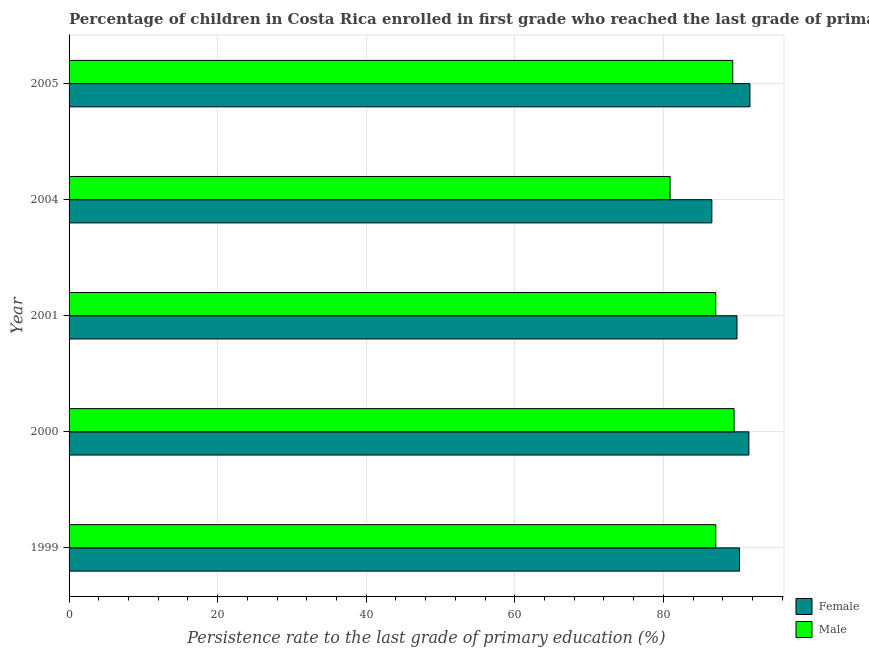How many different coloured bars are there?
Keep it short and to the point. 2. How many groups of bars are there?
Provide a succinct answer. 5. Are the number of bars per tick equal to the number of legend labels?
Provide a short and direct response. Yes. How many bars are there on the 3rd tick from the bottom?
Offer a terse response. 2. What is the label of the 2nd group of bars from the top?
Your answer should be very brief. 2004. In how many cases, is the number of bars for a given year not equal to the number of legend labels?
Provide a short and direct response. 0. What is the persistence rate of female students in 2005?
Make the answer very short. 91.65. Across all years, what is the maximum persistence rate of male students?
Provide a short and direct response. 89.52. Across all years, what is the minimum persistence rate of female students?
Make the answer very short. 86.52. In which year was the persistence rate of male students maximum?
Make the answer very short. 2000. In which year was the persistence rate of male students minimum?
Provide a short and direct response. 2004. What is the total persistence rate of male students in the graph?
Your answer should be very brief. 433.84. What is the difference between the persistence rate of female students in 1999 and that in 2000?
Ensure brevity in your answer.  -1.26. What is the difference between the persistence rate of female students in 2000 and the persistence rate of male students in 1999?
Provide a succinct answer. 4.45. What is the average persistence rate of female students per year?
Provide a short and direct response. 89.96. In the year 2004, what is the difference between the persistence rate of female students and persistence rate of male students?
Your answer should be very brief. 5.62. In how many years, is the persistence rate of female students greater than 92 %?
Offer a very short reply. 0. Is the persistence rate of female students in 2000 less than that in 2001?
Provide a short and direct response. No. Is the difference between the persistence rate of female students in 2001 and 2005 greater than the difference between the persistence rate of male students in 2001 and 2005?
Keep it short and to the point. Yes. What is the difference between the highest and the second highest persistence rate of female students?
Provide a succinct answer. 0.14. What is the difference between the highest and the lowest persistence rate of female students?
Ensure brevity in your answer.  5.13. Are all the bars in the graph horizontal?
Provide a short and direct response. Yes. How many years are there in the graph?
Your answer should be compact. 5. What is the difference between two consecutive major ticks on the X-axis?
Offer a terse response. 20. Does the graph contain any zero values?
Ensure brevity in your answer.  No. Where does the legend appear in the graph?
Your answer should be compact. Bottom right. How are the legend labels stacked?
Provide a succinct answer. Vertical. What is the title of the graph?
Provide a succinct answer. Percentage of children in Costa Rica enrolled in first grade who reached the last grade of primary education. Does "Diesel" appear as one of the legend labels in the graph?
Offer a very short reply. No. What is the label or title of the X-axis?
Your response must be concise. Persistence rate to the last grade of primary education (%). What is the Persistence rate to the last grade of primary education (%) in Female in 1999?
Give a very brief answer. 90.24. What is the Persistence rate to the last grade of primary education (%) in Male in 1999?
Ensure brevity in your answer.  87.05. What is the Persistence rate to the last grade of primary education (%) in Female in 2000?
Keep it short and to the point. 91.5. What is the Persistence rate to the last grade of primary education (%) of Male in 2000?
Provide a succinct answer. 89.52. What is the Persistence rate to the last grade of primary education (%) in Female in 2001?
Offer a very short reply. 89.9. What is the Persistence rate to the last grade of primary education (%) of Male in 2001?
Provide a short and direct response. 87.04. What is the Persistence rate to the last grade of primary education (%) of Female in 2004?
Your answer should be compact. 86.52. What is the Persistence rate to the last grade of primary education (%) of Male in 2004?
Offer a very short reply. 80.9. What is the Persistence rate to the last grade of primary education (%) of Female in 2005?
Offer a very short reply. 91.65. What is the Persistence rate to the last grade of primary education (%) of Male in 2005?
Make the answer very short. 89.33. Across all years, what is the maximum Persistence rate to the last grade of primary education (%) of Female?
Your answer should be compact. 91.65. Across all years, what is the maximum Persistence rate to the last grade of primary education (%) in Male?
Make the answer very short. 89.52. Across all years, what is the minimum Persistence rate to the last grade of primary education (%) in Female?
Offer a very short reply. 86.52. Across all years, what is the minimum Persistence rate to the last grade of primary education (%) of Male?
Provide a short and direct response. 80.9. What is the total Persistence rate to the last grade of primary education (%) of Female in the graph?
Make the answer very short. 449.81. What is the total Persistence rate to the last grade of primary education (%) of Male in the graph?
Make the answer very short. 433.84. What is the difference between the Persistence rate to the last grade of primary education (%) in Female in 1999 and that in 2000?
Your answer should be very brief. -1.26. What is the difference between the Persistence rate to the last grade of primary education (%) in Male in 1999 and that in 2000?
Offer a terse response. -2.47. What is the difference between the Persistence rate to the last grade of primary education (%) in Female in 1999 and that in 2001?
Offer a very short reply. 0.34. What is the difference between the Persistence rate to the last grade of primary education (%) in Male in 1999 and that in 2001?
Provide a succinct answer. 0.01. What is the difference between the Persistence rate to the last grade of primary education (%) in Female in 1999 and that in 2004?
Provide a short and direct response. 3.72. What is the difference between the Persistence rate to the last grade of primary education (%) of Male in 1999 and that in 2004?
Offer a terse response. 6.15. What is the difference between the Persistence rate to the last grade of primary education (%) of Female in 1999 and that in 2005?
Provide a succinct answer. -1.41. What is the difference between the Persistence rate to the last grade of primary education (%) in Male in 1999 and that in 2005?
Make the answer very short. -2.28. What is the difference between the Persistence rate to the last grade of primary education (%) in Female in 2000 and that in 2001?
Provide a succinct answer. 1.6. What is the difference between the Persistence rate to the last grade of primary education (%) in Male in 2000 and that in 2001?
Provide a succinct answer. 2.47. What is the difference between the Persistence rate to the last grade of primary education (%) of Female in 2000 and that in 2004?
Your answer should be very brief. 4.98. What is the difference between the Persistence rate to the last grade of primary education (%) of Male in 2000 and that in 2004?
Provide a succinct answer. 8.62. What is the difference between the Persistence rate to the last grade of primary education (%) of Female in 2000 and that in 2005?
Provide a succinct answer. -0.14. What is the difference between the Persistence rate to the last grade of primary education (%) of Male in 2000 and that in 2005?
Provide a succinct answer. 0.18. What is the difference between the Persistence rate to the last grade of primary education (%) in Female in 2001 and that in 2004?
Your answer should be very brief. 3.38. What is the difference between the Persistence rate to the last grade of primary education (%) of Male in 2001 and that in 2004?
Give a very brief answer. 6.14. What is the difference between the Persistence rate to the last grade of primary education (%) of Female in 2001 and that in 2005?
Offer a terse response. -1.75. What is the difference between the Persistence rate to the last grade of primary education (%) in Male in 2001 and that in 2005?
Provide a succinct answer. -2.29. What is the difference between the Persistence rate to the last grade of primary education (%) of Female in 2004 and that in 2005?
Offer a very short reply. -5.13. What is the difference between the Persistence rate to the last grade of primary education (%) in Male in 2004 and that in 2005?
Provide a succinct answer. -8.44. What is the difference between the Persistence rate to the last grade of primary education (%) of Female in 1999 and the Persistence rate to the last grade of primary education (%) of Male in 2000?
Give a very brief answer. 0.73. What is the difference between the Persistence rate to the last grade of primary education (%) in Female in 1999 and the Persistence rate to the last grade of primary education (%) in Male in 2001?
Ensure brevity in your answer.  3.2. What is the difference between the Persistence rate to the last grade of primary education (%) of Female in 1999 and the Persistence rate to the last grade of primary education (%) of Male in 2004?
Provide a short and direct response. 9.34. What is the difference between the Persistence rate to the last grade of primary education (%) of Female in 1999 and the Persistence rate to the last grade of primary education (%) of Male in 2005?
Your response must be concise. 0.91. What is the difference between the Persistence rate to the last grade of primary education (%) of Female in 2000 and the Persistence rate to the last grade of primary education (%) of Male in 2001?
Provide a short and direct response. 4.46. What is the difference between the Persistence rate to the last grade of primary education (%) of Female in 2000 and the Persistence rate to the last grade of primary education (%) of Male in 2004?
Your answer should be compact. 10.61. What is the difference between the Persistence rate to the last grade of primary education (%) in Female in 2000 and the Persistence rate to the last grade of primary education (%) in Male in 2005?
Give a very brief answer. 2.17. What is the difference between the Persistence rate to the last grade of primary education (%) of Female in 2001 and the Persistence rate to the last grade of primary education (%) of Male in 2004?
Offer a very short reply. 9. What is the difference between the Persistence rate to the last grade of primary education (%) in Female in 2001 and the Persistence rate to the last grade of primary education (%) in Male in 2005?
Give a very brief answer. 0.57. What is the difference between the Persistence rate to the last grade of primary education (%) in Female in 2004 and the Persistence rate to the last grade of primary education (%) in Male in 2005?
Offer a terse response. -2.81. What is the average Persistence rate to the last grade of primary education (%) in Female per year?
Ensure brevity in your answer.  89.96. What is the average Persistence rate to the last grade of primary education (%) in Male per year?
Give a very brief answer. 86.77. In the year 1999, what is the difference between the Persistence rate to the last grade of primary education (%) of Female and Persistence rate to the last grade of primary education (%) of Male?
Provide a succinct answer. 3.19. In the year 2000, what is the difference between the Persistence rate to the last grade of primary education (%) in Female and Persistence rate to the last grade of primary education (%) in Male?
Make the answer very short. 1.99. In the year 2001, what is the difference between the Persistence rate to the last grade of primary education (%) of Female and Persistence rate to the last grade of primary education (%) of Male?
Make the answer very short. 2.86. In the year 2004, what is the difference between the Persistence rate to the last grade of primary education (%) in Female and Persistence rate to the last grade of primary education (%) in Male?
Offer a very short reply. 5.62. In the year 2005, what is the difference between the Persistence rate to the last grade of primary education (%) in Female and Persistence rate to the last grade of primary education (%) in Male?
Offer a very short reply. 2.31. What is the ratio of the Persistence rate to the last grade of primary education (%) in Female in 1999 to that in 2000?
Offer a very short reply. 0.99. What is the ratio of the Persistence rate to the last grade of primary education (%) in Male in 1999 to that in 2000?
Your answer should be compact. 0.97. What is the ratio of the Persistence rate to the last grade of primary education (%) in Male in 1999 to that in 2001?
Ensure brevity in your answer.  1. What is the ratio of the Persistence rate to the last grade of primary education (%) in Female in 1999 to that in 2004?
Your answer should be compact. 1.04. What is the ratio of the Persistence rate to the last grade of primary education (%) in Male in 1999 to that in 2004?
Your response must be concise. 1.08. What is the ratio of the Persistence rate to the last grade of primary education (%) in Female in 1999 to that in 2005?
Provide a succinct answer. 0.98. What is the ratio of the Persistence rate to the last grade of primary education (%) of Male in 1999 to that in 2005?
Keep it short and to the point. 0.97. What is the ratio of the Persistence rate to the last grade of primary education (%) of Female in 2000 to that in 2001?
Make the answer very short. 1.02. What is the ratio of the Persistence rate to the last grade of primary education (%) of Male in 2000 to that in 2001?
Provide a short and direct response. 1.03. What is the ratio of the Persistence rate to the last grade of primary education (%) in Female in 2000 to that in 2004?
Your answer should be very brief. 1.06. What is the ratio of the Persistence rate to the last grade of primary education (%) in Male in 2000 to that in 2004?
Offer a very short reply. 1.11. What is the ratio of the Persistence rate to the last grade of primary education (%) in Female in 2000 to that in 2005?
Your answer should be compact. 1. What is the ratio of the Persistence rate to the last grade of primary education (%) of Female in 2001 to that in 2004?
Ensure brevity in your answer.  1.04. What is the ratio of the Persistence rate to the last grade of primary education (%) in Male in 2001 to that in 2004?
Offer a terse response. 1.08. What is the ratio of the Persistence rate to the last grade of primary education (%) of Female in 2001 to that in 2005?
Your answer should be compact. 0.98. What is the ratio of the Persistence rate to the last grade of primary education (%) of Male in 2001 to that in 2005?
Your response must be concise. 0.97. What is the ratio of the Persistence rate to the last grade of primary education (%) of Female in 2004 to that in 2005?
Your response must be concise. 0.94. What is the ratio of the Persistence rate to the last grade of primary education (%) in Male in 2004 to that in 2005?
Your answer should be very brief. 0.91. What is the difference between the highest and the second highest Persistence rate to the last grade of primary education (%) of Female?
Your answer should be compact. 0.14. What is the difference between the highest and the second highest Persistence rate to the last grade of primary education (%) in Male?
Provide a short and direct response. 0.18. What is the difference between the highest and the lowest Persistence rate to the last grade of primary education (%) in Female?
Your answer should be compact. 5.13. What is the difference between the highest and the lowest Persistence rate to the last grade of primary education (%) of Male?
Give a very brief answer. 8.62. 